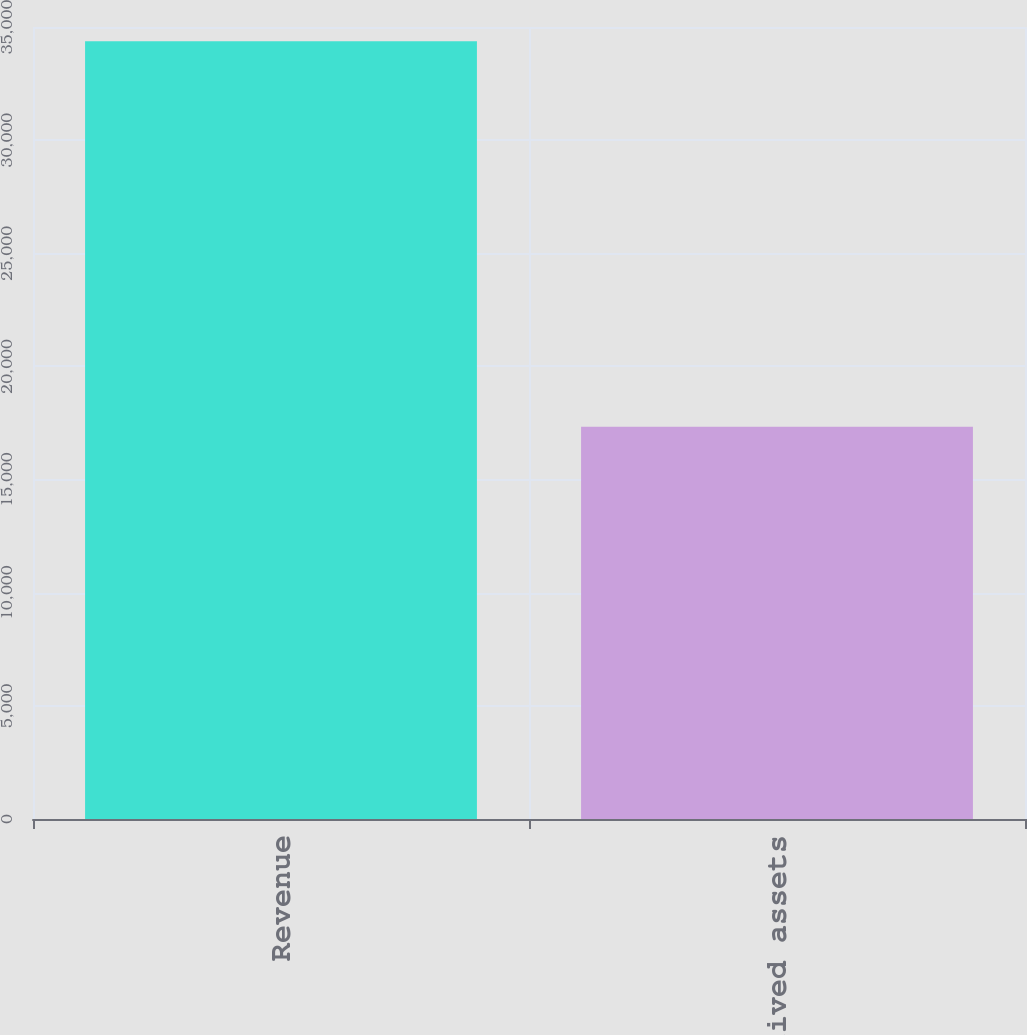Convert chart to OTSL. <chart><loc_0><loc_0><loc_500><loc_500><bar_chart><fcel>Revenue<fcel>Long-lived assets<nl><fcel>34375<fcel>17336<nl></chart> 